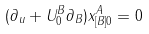<formula> <loc_0><loc_0><loc_500><loc_500>( \partial _ { u } + U ^ { B } _ { 0 } \partial _ { B } ) x _ { [ B ] 0 } ^ { A } = 0</formula> 